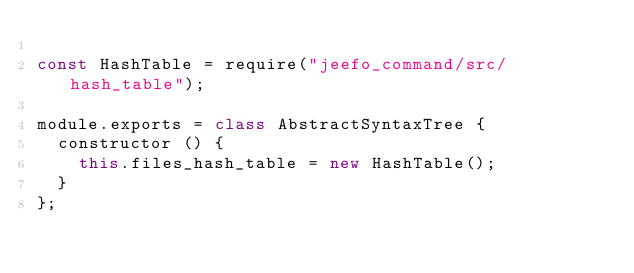Convert code to text. <code><loc_0><loc_0><loc_500><loc_500><_JavaScript_>
const HashTable = require("jeefo_command/src/hash_table");

module.exports = class AbstractSyntaxTree {
	constructor () {
		this.files_hash_table = new HashTable();
	}
};
</code> 